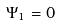<formula> <loc_0><loc_0><loc_500><loc_500>\Psi _ { 1 } = 0</formula> 